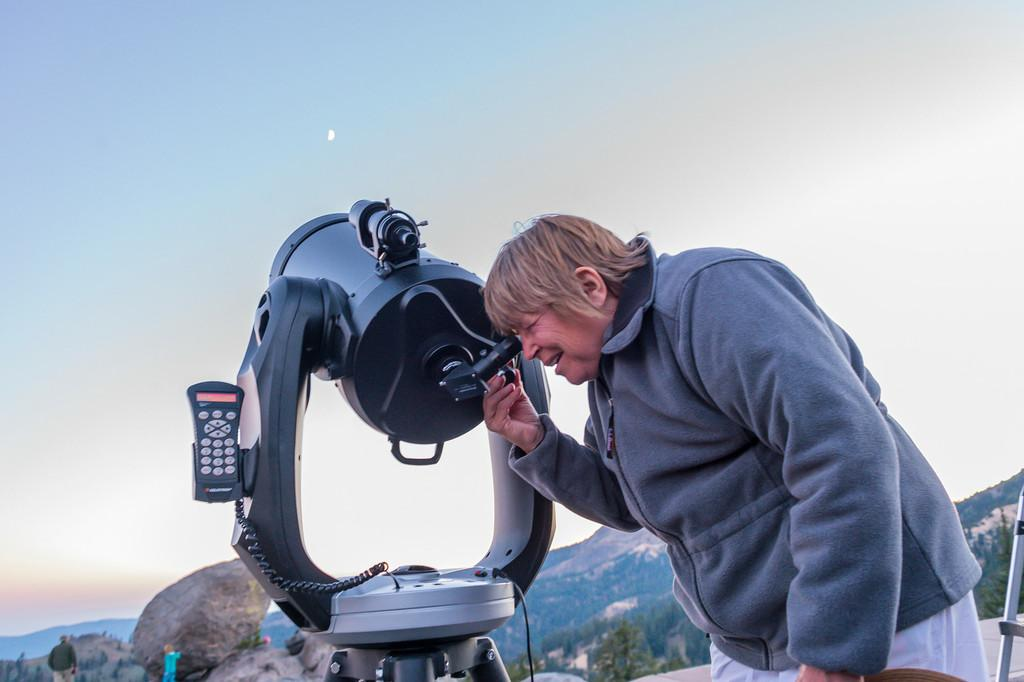What is the main subject of the image? There is a person in the image. What is the person wearing? The person is wearing a grey sweatshirt. What is the person doing in the image? The person is looking into a telescope. What is the telescope pointed towards? The telescope is pointed towards the sky. What can be seen in the background of the image? There are hills visible in the background of the image. How many cattle can be seen grazing in the image? There are no cattle present in the image. What type of map is the person holding while looking through the telescope? The person is not holding a map in the image; they are looking through a telescope pointed towards the sky. 